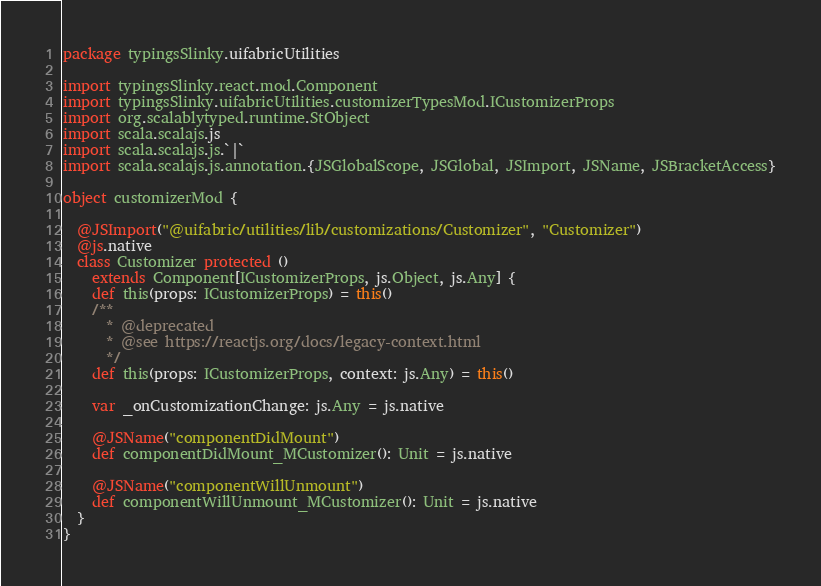<code> <loc_0><loc_0><loc_500><loc_500><_Scala_>package typingsSlinky.uifabricUtilities

import typingsSlinky.react.mod.Component
import typingsSlinky.uifabricUtilities.customizerTypesMod.ICustomizerProps
import org.scalablytyped.runtime.StObject
import scala.scalajs.js
import scala.scalajs.js.`|`
import scala.scalajs.js.annotation.{JSGlobalScope, JSGlobal, JSImport, JSName, JSBracketAccess}

object customizerMod {
  
  @JSImport("@uifabric/utilities/lib/customizations/Customizer", "Customizer")
  @js.native
  class Customizer protected ()
    extends Component[ICustomizerProps, js.Object, js.Any] {
    def this(props: ICustomizerProps) = this()
    /**
      * @deprecated
      * @see https://reactjs.org/docs/legacy-context.html
      */
    def this(props: ICustomizerProps, context: js.Any) = this()
    
    var _onCustomizationChange: js.Any = js.native
    
    @JSName("componentDidMount")
    def componentDidMount_MCustomizer(): Unit = js.native
    
    @JSName("componentWillUnmount")
    def componentWillUnmount_MCustomizer(): Unit = js.native
  }
}
</code> 